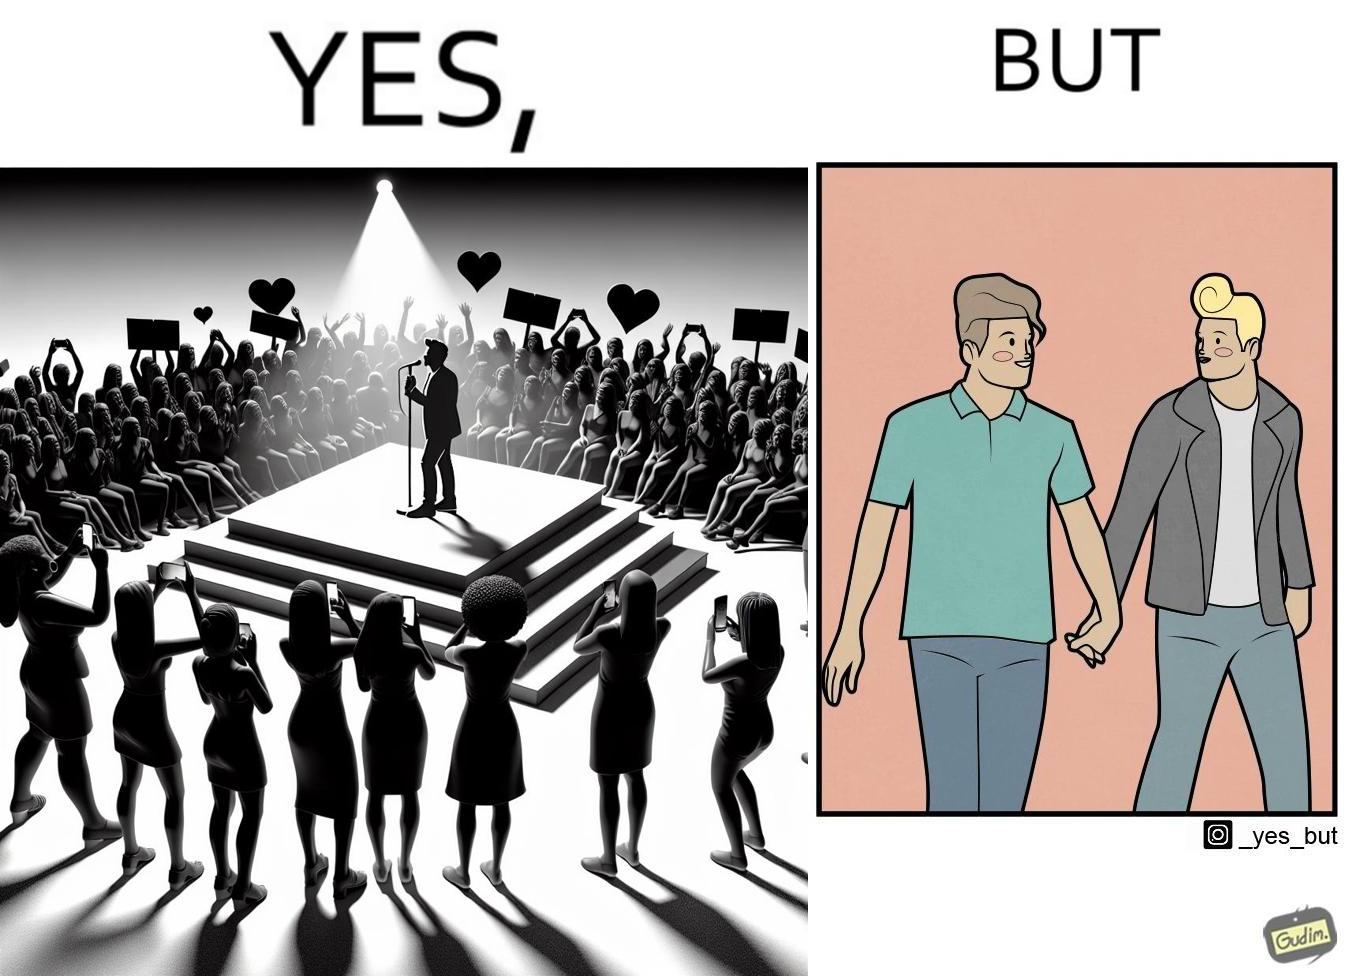Describe what you see in the left and right parts of this image. In the left part of the image: The person shows a man singing on a platform under a spotlight. There are several girls around the platform enjoying his singing and cheering for him. A few girls are taking his photos using their phone and a few also have a poster with heart drawn on it. In the right part of the image: The image shows two men holding hands. 